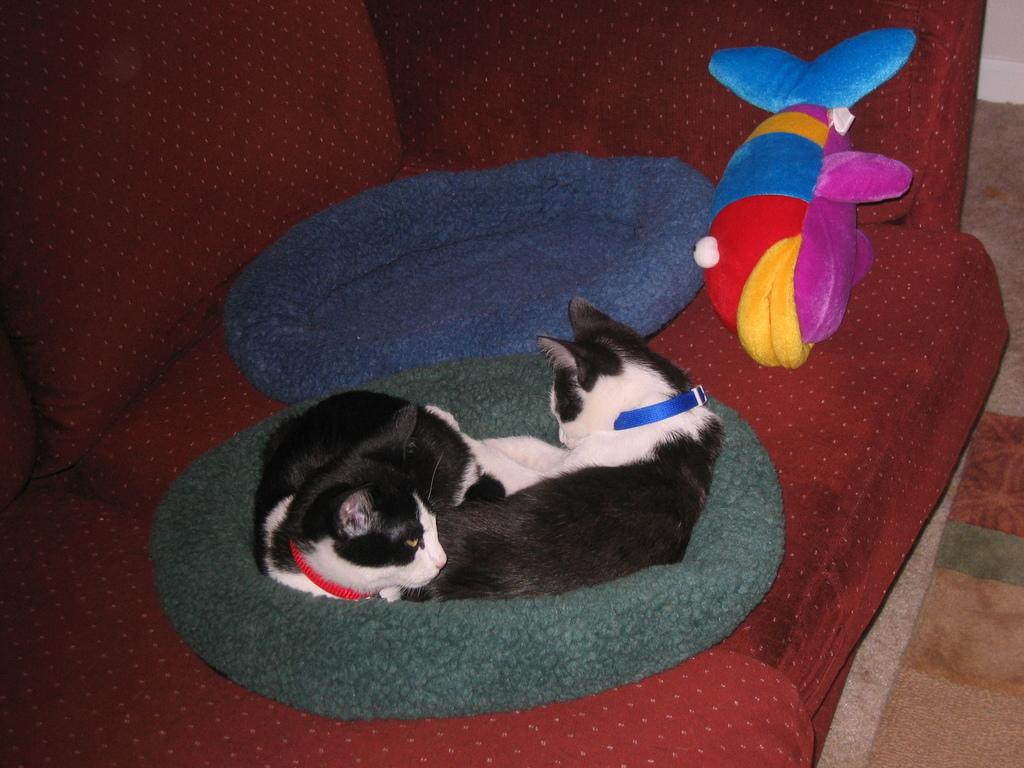What animals are on the bag in the image? There are two cats on a bag in the image. Where is the bag with the cats placed? The bag is placed on a couch. Are there any other bags visible in the image? Yes, there is another bag on the couch. What else can be seen on the couch? There is a toy on the couch. Who is visible in the image? A man is visible in the bottom right of the image. What part of the room can be seen in the image? The floor is visible in the image. How many geese are flying over the couch in the image? There are no geese visible in the image; it only shows two cats on a bag, another bag, a toy, a man, and a couch. What type of wound is the man treating on the couch in the image? There is no wound or any indication of medical treatment in the image; it only shows a man, two cats on a bag, another bag, and a toy on a couch. 